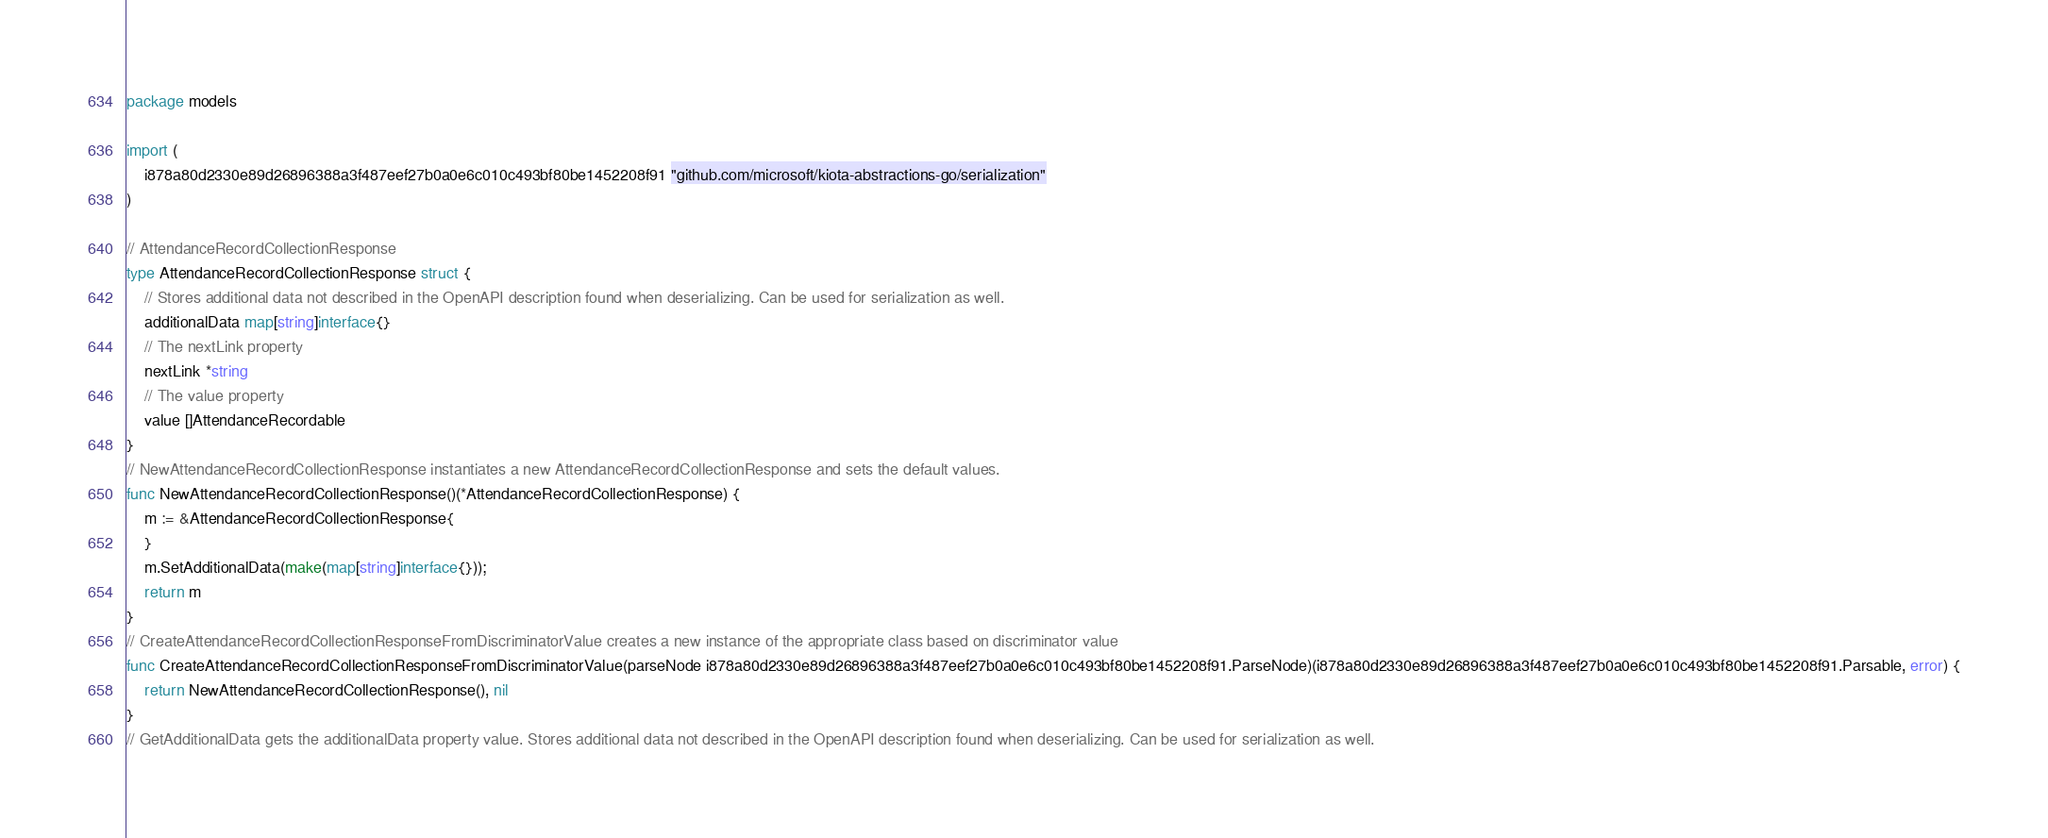Convert code to text. <code><loc_0><loc_0><loc_500><loc_500><_Go_>package models

import (
    i878a80d2330e89d26896388a3f487eef27b0a0e6c010c493bf80be1452208f91 "github.com/microsoft/kiota-abstractions-go/serialization"
)

// AttendanceRecordCollectionResponse 
type AttendanceRecordCollectionResponse struct {
    // Stores additional data not described in the OpenAPI description found when deserializing. Can be used for serialization as well.
    additionalData map[string]interface{}
    // The nextLink property
    nextLink *string
    // The value property
    value []AttendanceRecordable
}
// NewAttendanceRecordCollectionResponse instantiates a new AttendanceRecordCollectionResponse and sets the default values.
func NewAttendanceRecordCollectionResponse()(*AttendanceRecordCollectionResponse) {
    m := &AttendanceRecordCollectionResponse{
    }
    m.SetAdditionalData(make(map[string]interface{}));
    return m
}
// CreateAttendanceRecordCollectionResponseFromDiscriminatorValue creates a new instance of the appropriate class based on discriminator value
func CreateAttendanceRecordCollectionResponseFromDiscriminatorValue(parseNode i878a80d2330e89d26896388a3f487eef27b0a0e6c010c493bf80be1452208f91.ParseNode)(i878a80d2330e89d26896388a3f487eef27b0a0e6c010c493bf80be1452208f91.Parsable, error) {
    return NewAttendanceRecordCollectionResponse(), nil
}
// GetAdditionalData gets the additionalData property value. Stores additional data not described in the OpenAPI description found when deserializing. Can be used for serialization as well.</code> 